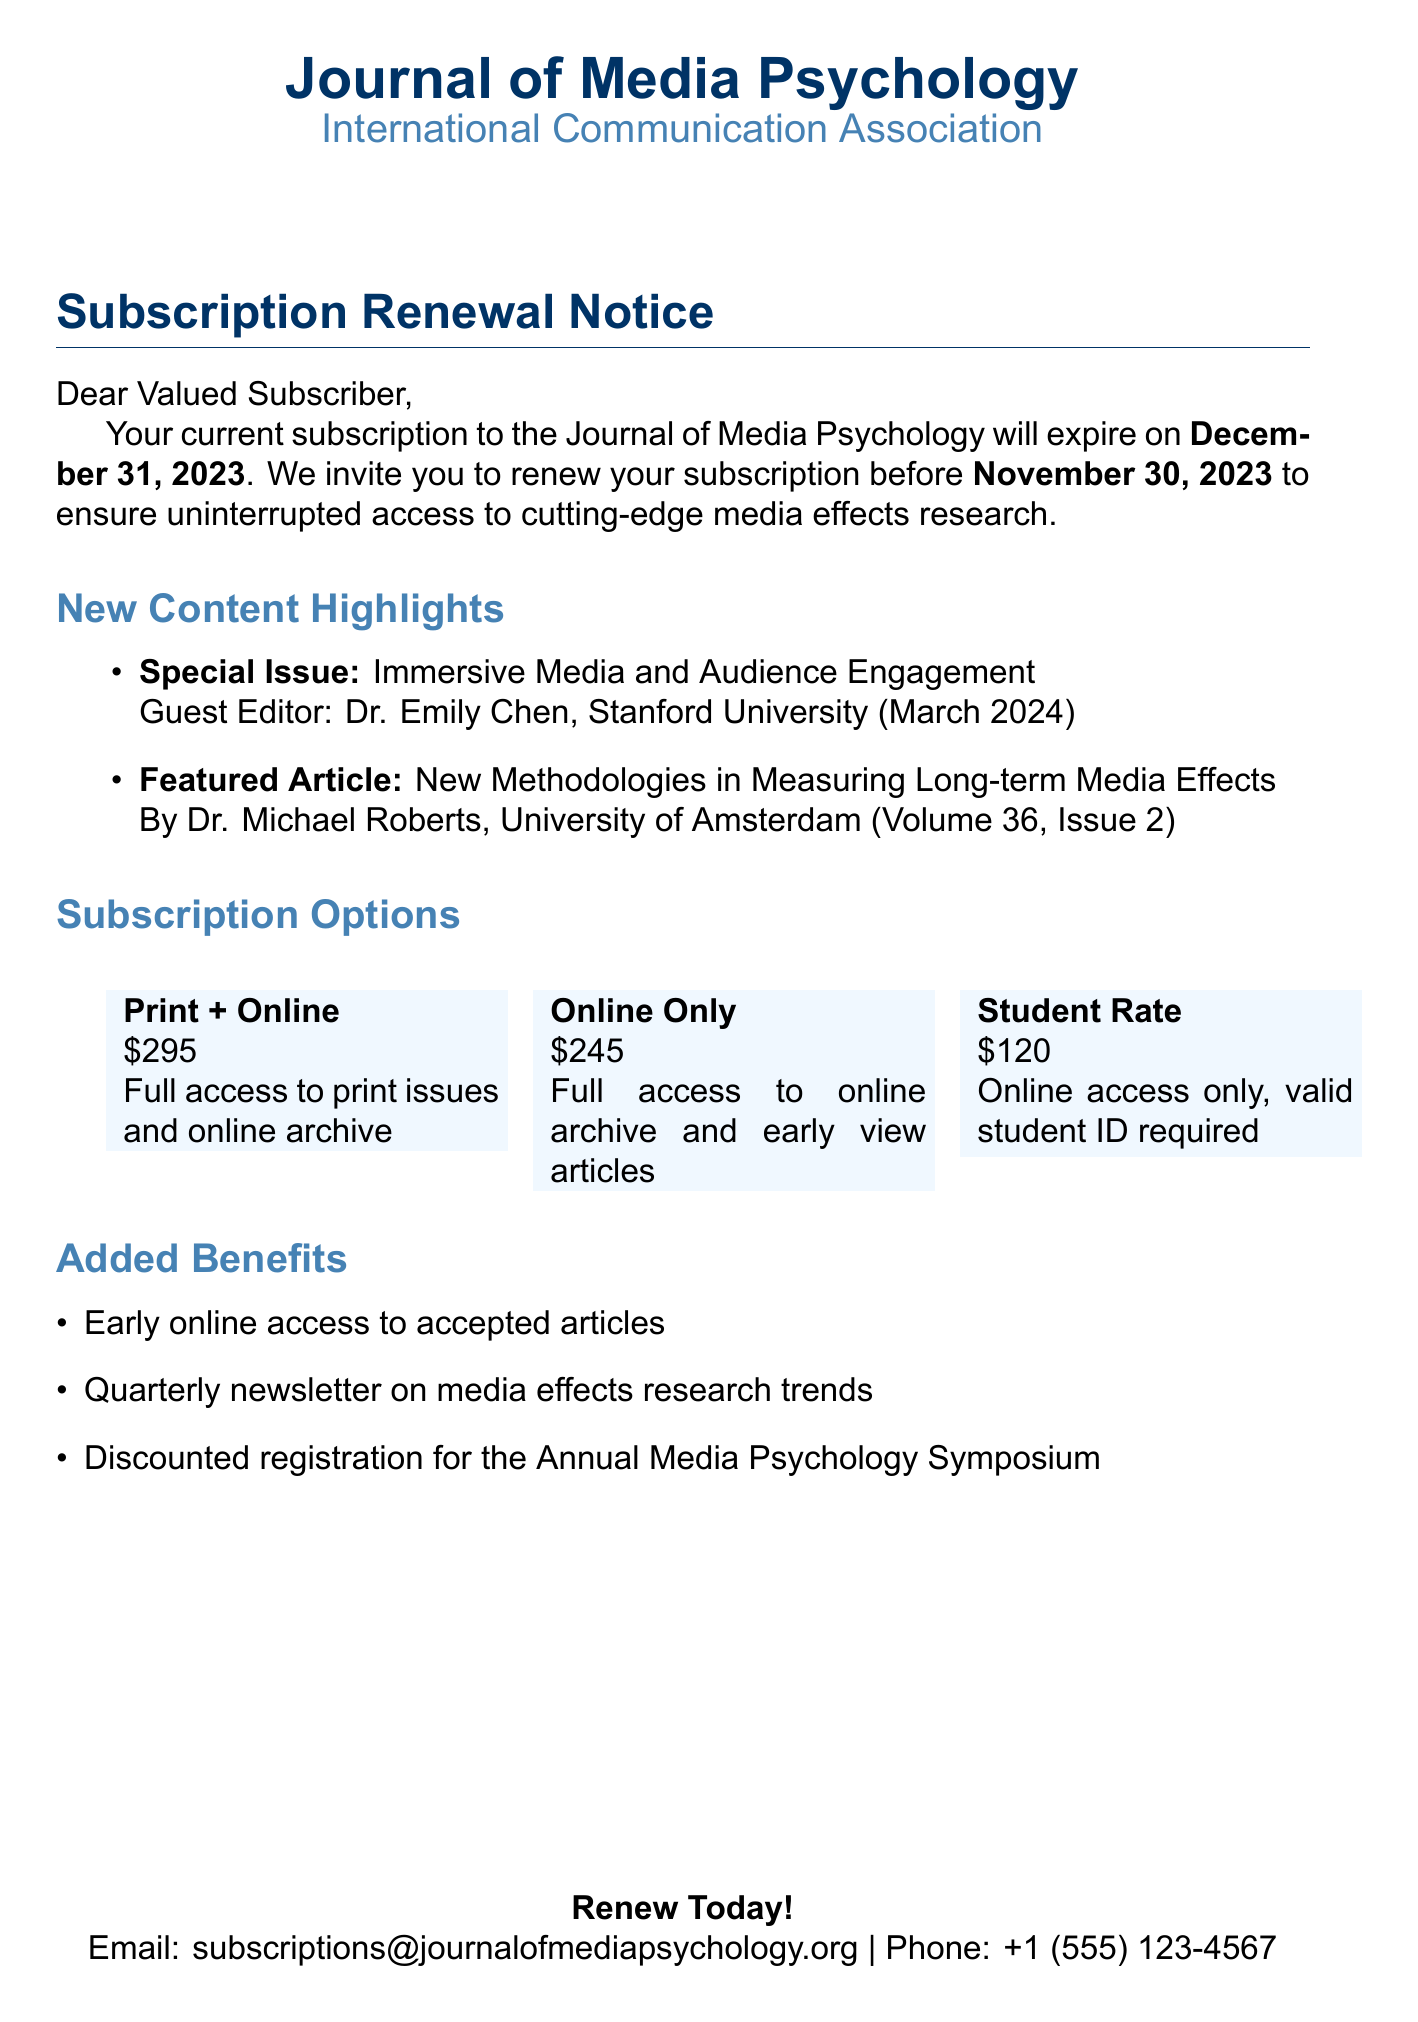What is the name of the journal? The journal is specifically identified at the start of the document.
Answer: Journal of Media Psychology Who is the guest editor for the special issue? The document highlights new content including the guest editor for the special issue in the new content section.
Answer: Dr. Emily Chen What is the price of the Student Rate subscription? Pricing options for subscriptions are detailed, specifically mentioning the cost for the student rate.
Answer: $120 What is the renewal deadline? The renewal deadline is clearly stated in the subscription renewal notice section of the document.
Answer: November 30, 2023 When will the special issue on Immersive Media be published? The publication date for the special issue is provided among the new content highlights.
Answer: March 2024 What additional benefit is included with the subscription? The document lists added benefits that come with the subscription renewal.
Answer: Early online access to accepted articles How many pricing options are offered? The pricing options are enumerated in the subscription options section.
Answer: Three What is the phone contact provided for inquiries? The document includes contact information, specifically for phone inquiries.
Answer: +1 (555) 123-4567 What is the current subscription expiry date? The expiry date is specified explicitly in the renewal notice.
Answer: December 31, 2023 